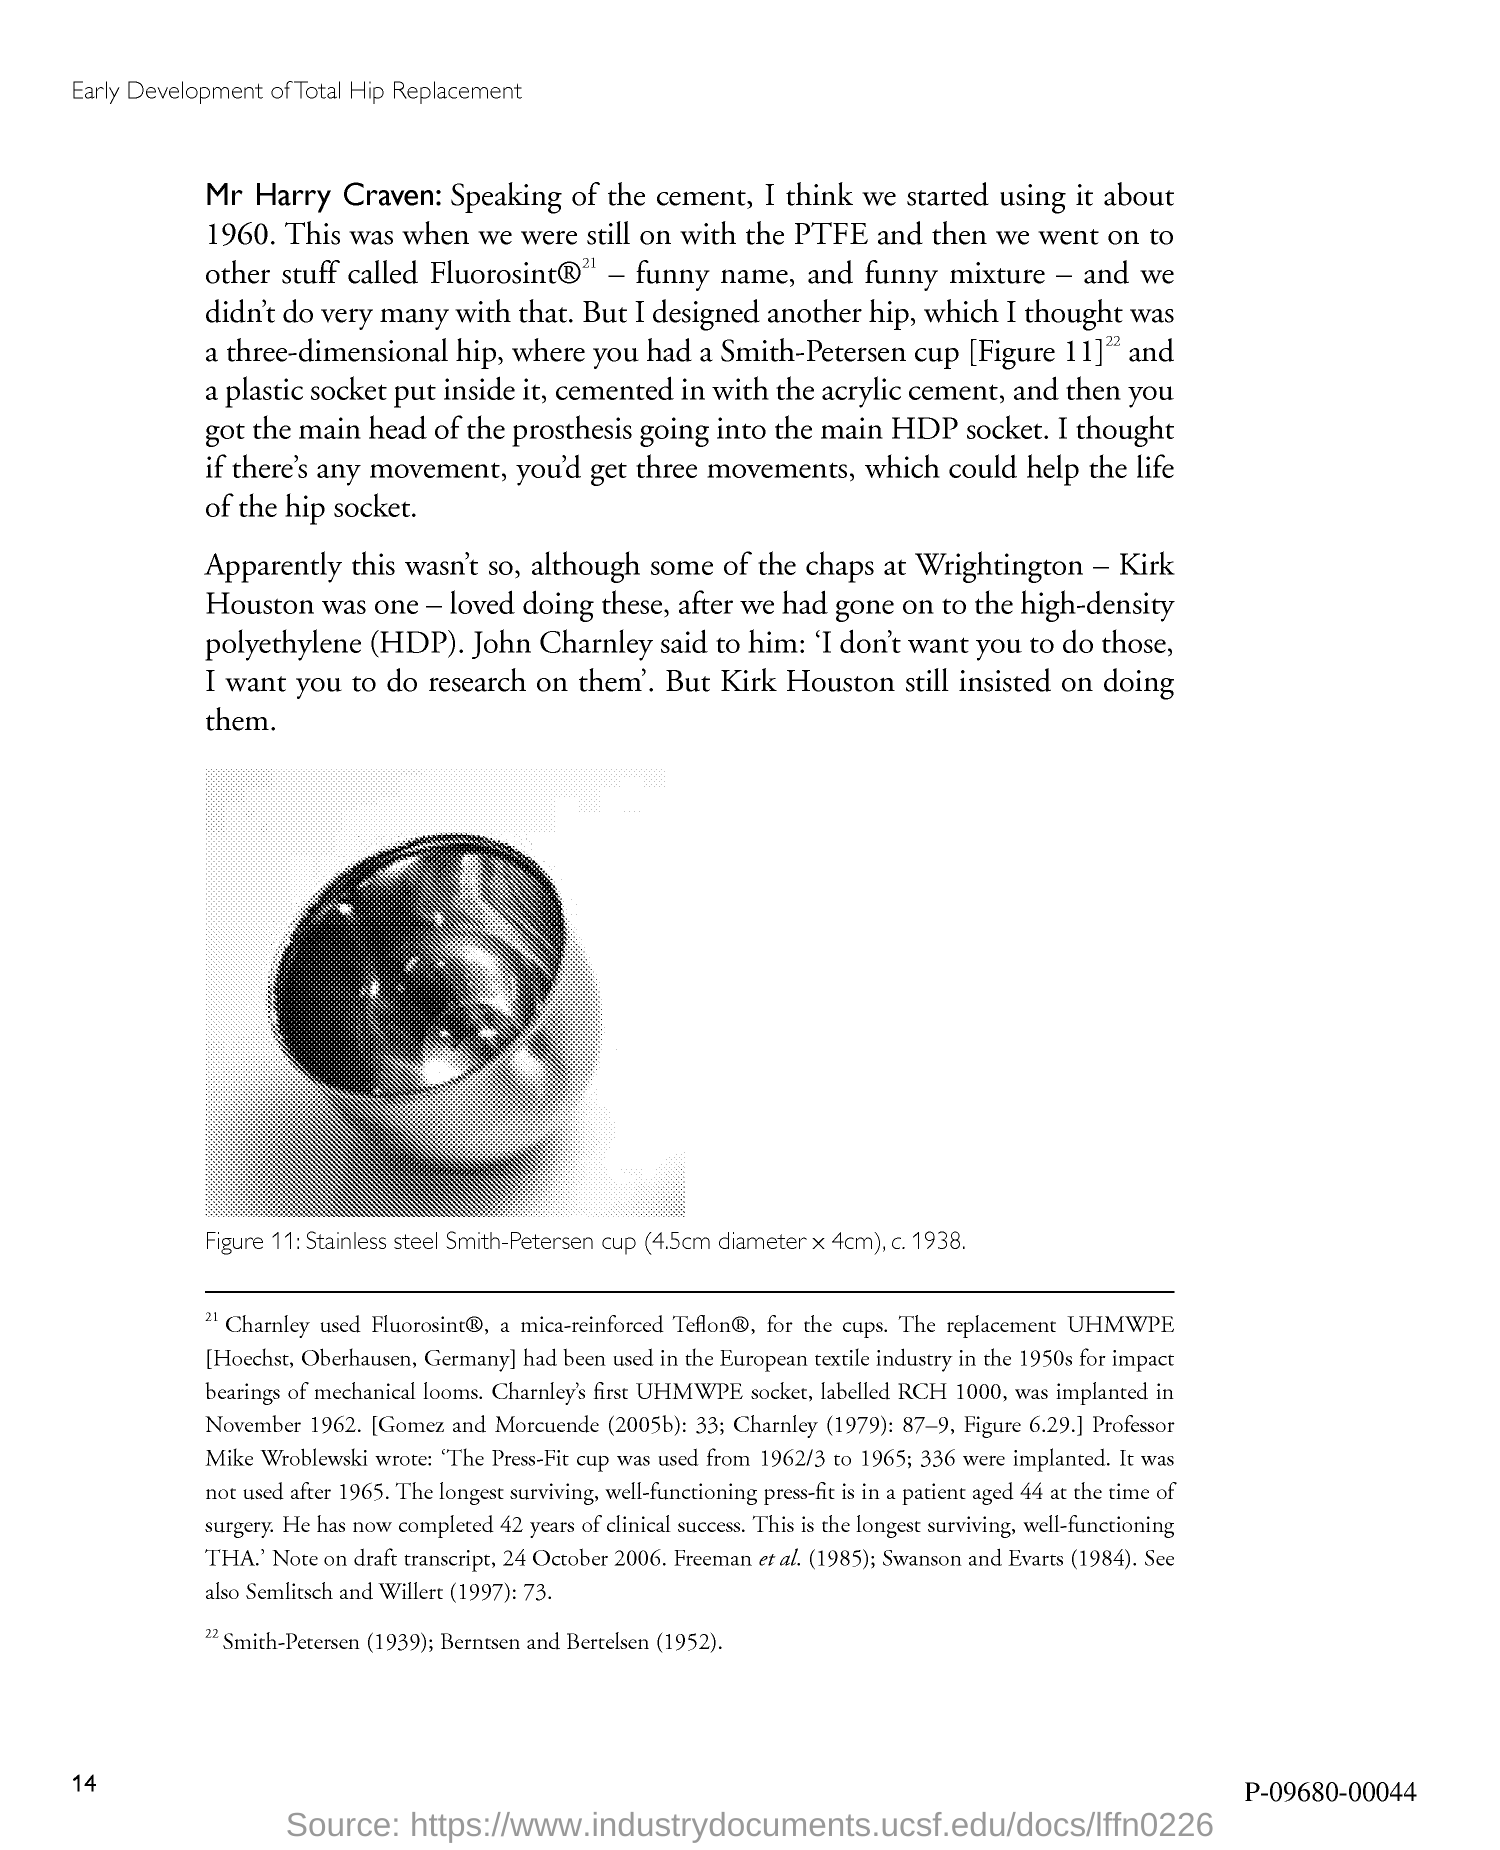Mention a couple of crucial points in this snapshot. The page number is 14. 